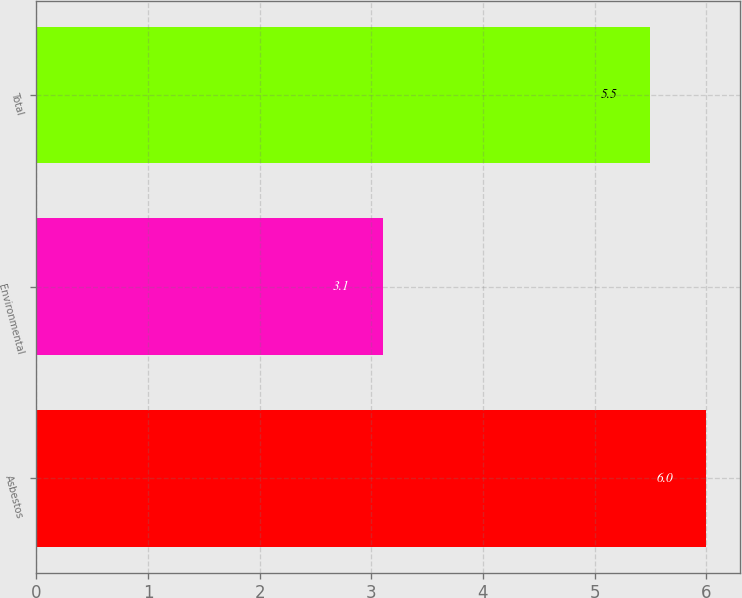Convert chart to OTSL. <chart><loc_0><loc_0><loc_500><loc_500><bar_chart><fcel>Asbestos<fcel>Environmental<fcel>Total<nl><fcel>6<fcel>3.1<fcel>5.5<nl></chart> 